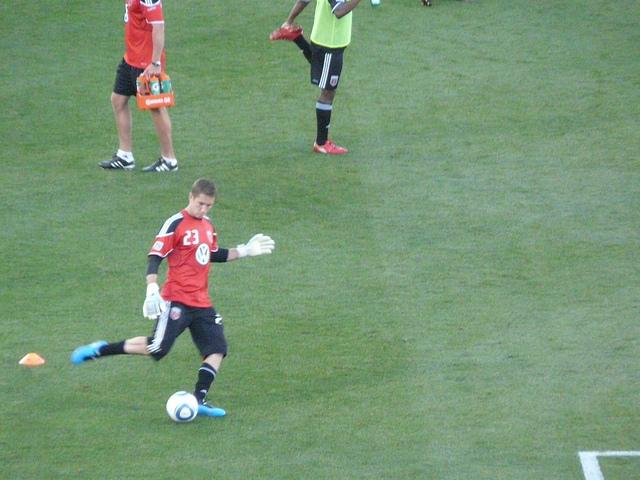What color is the grass?
Write a very short answer. Green. What game is being played?
Be succinct. Soccer. What number is on the guys' shirt?
Short answer required. 23. 